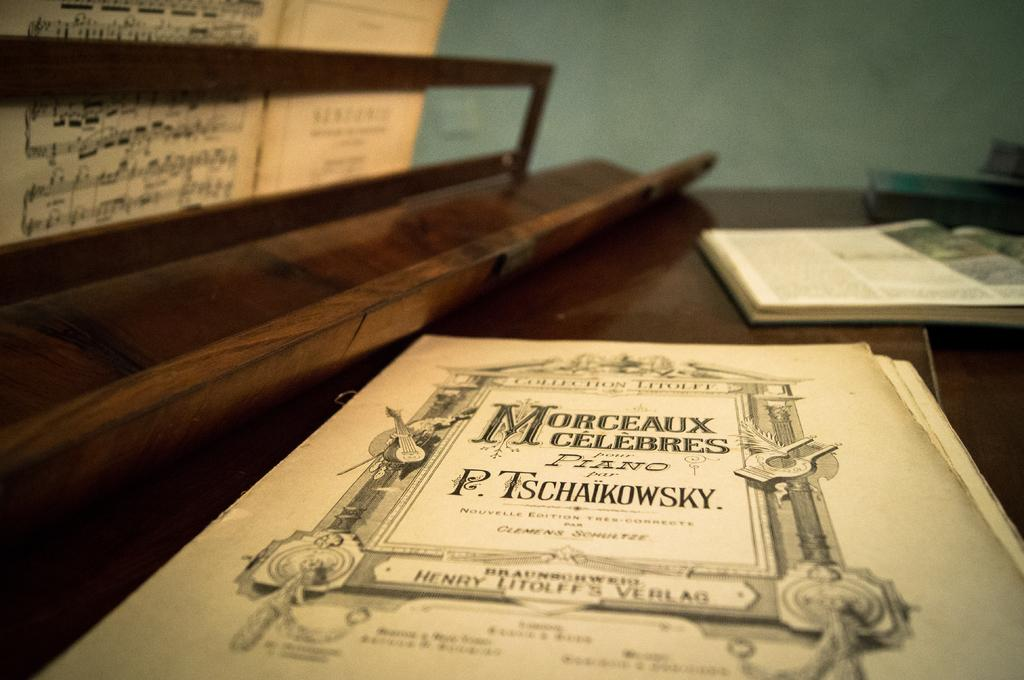<image>
Summarize the visual content of the image. a P. TSCHAIKOWSKY piano music book entitled MORCEAUX CELEBRES. 